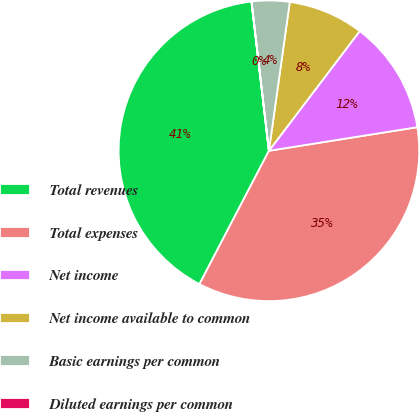<chart> <loc_0><loc_0><loc_500><loc_500><pie_chart><fcel>Total revenues<fcel>Total expenses<fcel>Net income<fcel>Net income available to common<fcel>Basic earnings per common<fcel>Diluted earnings per common<nl><fcel>40.5%<fcel>35.15%<fcel>12.16%<fcel>8.11%<fcel>4.06%<fcel>0.01%<nl></chart> 